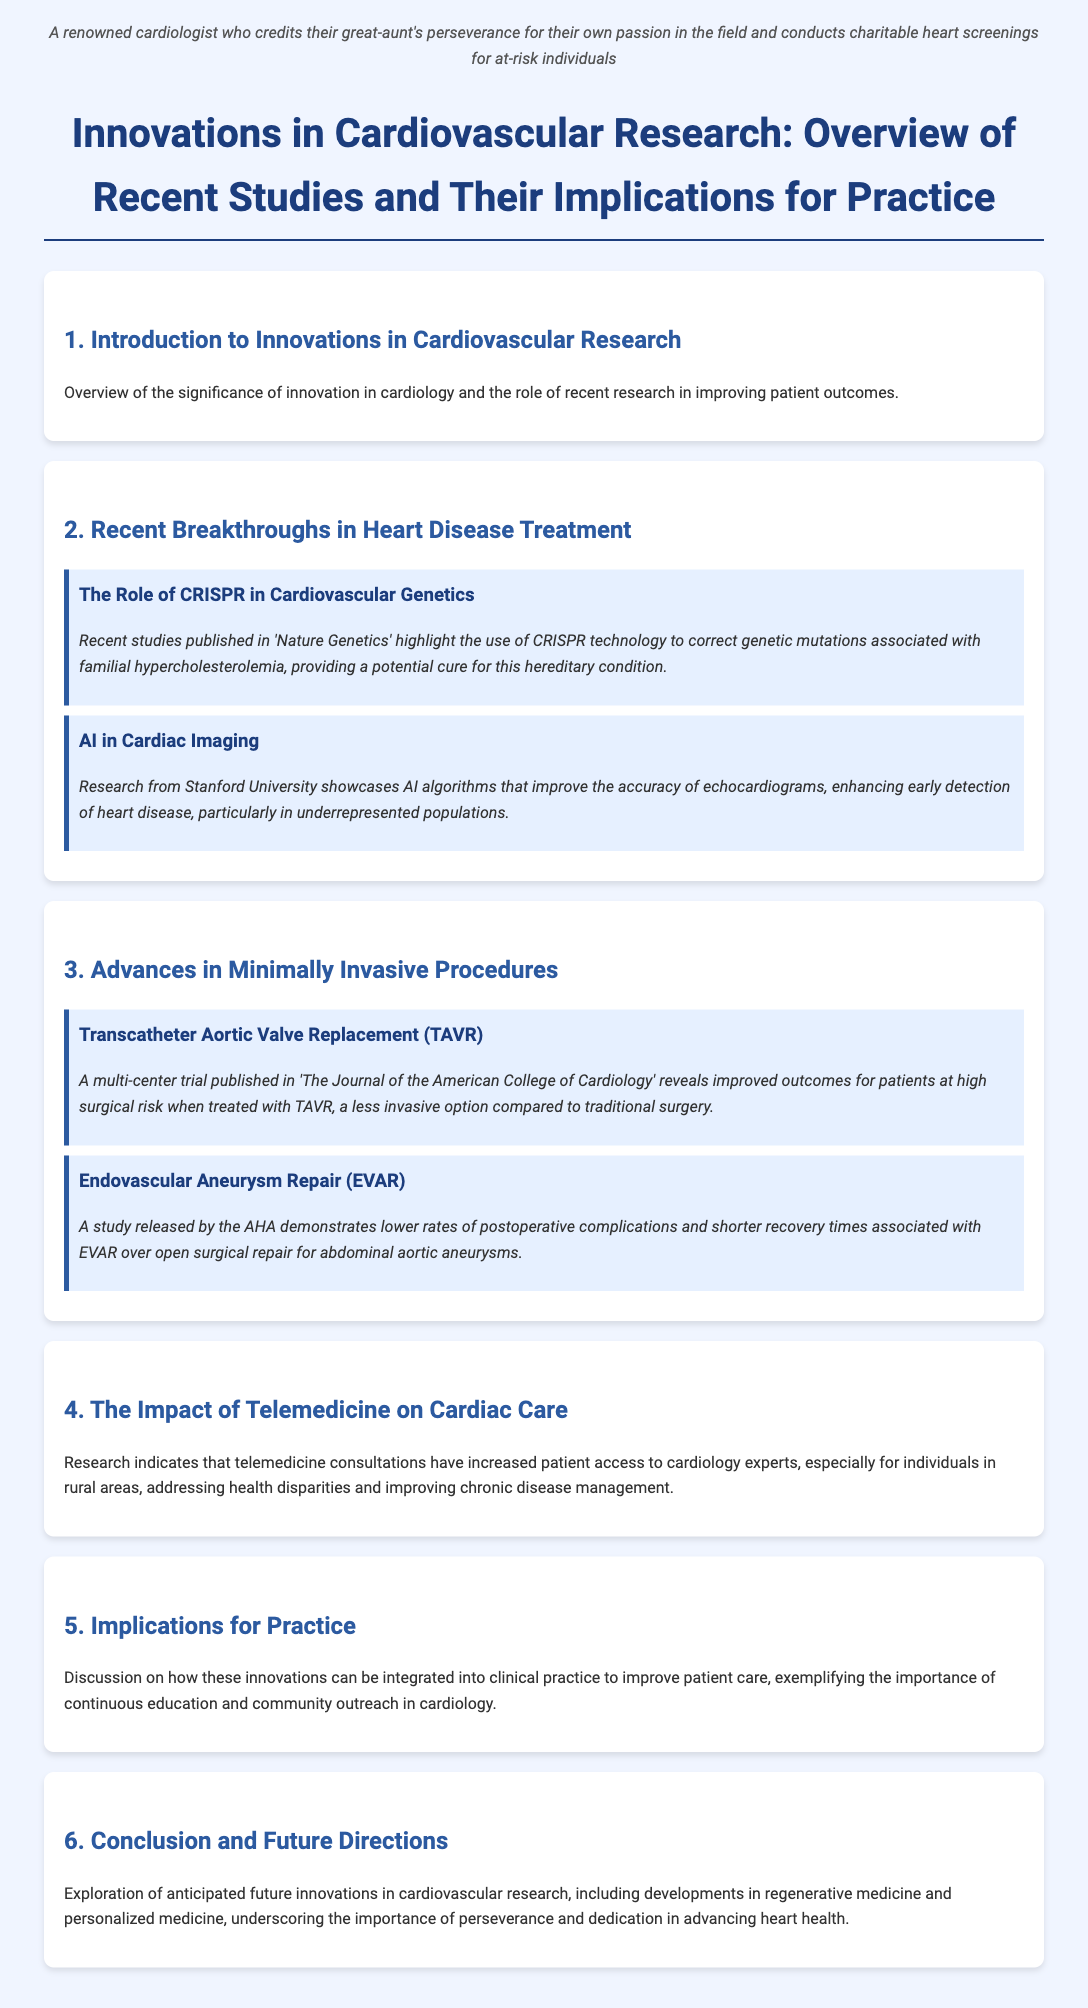What is the focus of the document? The document provides an overview of recent studies and their implications for practice in cardiovascular research.
Answer: Innovations in Cardiovascular Research Which technology is discussed for correcting genetic mutations? The document mentions CRISPR technology being used to address genetic mutations.
Answer: CRISPR What type of procedure does TAVR refer to? TAVR stands for Transcatheter Aortic Valve Replacement, as mentioned in the section on minimally invasive procedures.
Answer: Transcatheter Aortic Valve Replacement Which population benefits from AI in cardiac imaging? The AI algorithms improve the accuracy of echocardiograms, particularly helping underrepresented populations.
Answer: Underrepresented populations What are the anticipated future areas of innovation mentioned in the conclusion? The document mentions regenerative medicine and personalized medicine as future directions in cardiovascular research.
Answer: Regenerative medicine and personalized medicine How do telemedicine consultations impact patient care? Telemedicine increases patient access to cardiology experts, especially in rural areas.
Answer: Increased access What type of study is mentioned in relation to EVAR? The study concerning EVAR was released by the American Heart Association (AHA).
Answer: AHA How many sections are in the document? The document is divided into six main sections covering different topics in cardiovascular research.
Answer: Six What is one implication discussed for clinical practice? The document notes the importance of continuous education and community outreach in cardiology practice.
Answer: Continuous education and community outreach 